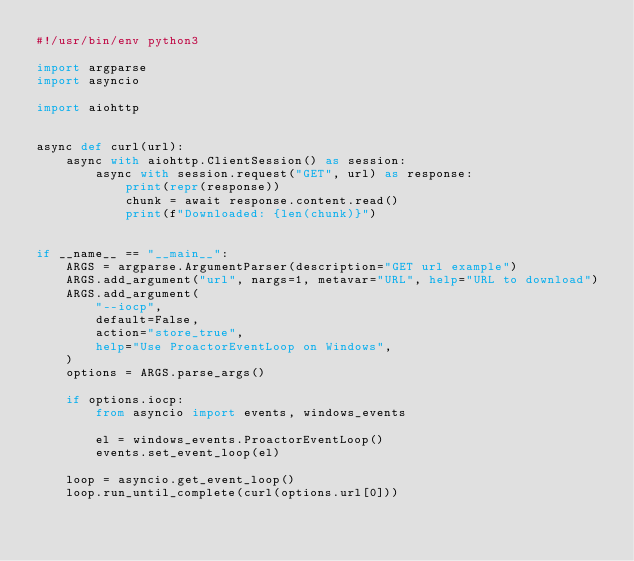Convert code to text. <code><loc_0><loc_0><loc_500><loc_500><_Python_>#!/usr/bin/env python3

import argparse
import asyncio

import aiohttp


async def curl(url):
    async with aiohttp.ClientSession() as session:
        async with session.request("GET", url) as response:
            print(repr(response))
            chunk = await response.content.read()
            print(f"Downloaded: {len(chunk)}")


if __name__ == "__main__":
    ARGS = argparse.ArgumentParser(description="GET url example")
    ARGS.add_argument("url", nargs=1, metavar="URL", help="URL to download")
    ARGS.add_argument(
        "--iocp",
        default=False,
        action="store_true",
        help="Use ProactorEventLoop on Windows",
    )
    options = ARGS.parse_args()

    if options.iocp:
        from asyncio import events, windows_events

        el = windows_events.ProactorEventLoop()
        events.set_event_loop(el)

    loop = asyncio.get_event_loop()
    loop.run_until_complete(curl(options.url[0]))
</code> 